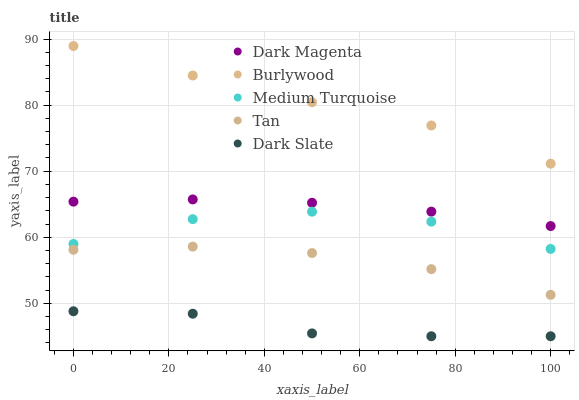Does Dark Slate have the minimum area under the curve?
Answer yes or no. Yes. Does Burlywood have the maximum area under the curve?
Answer yes or no. Yes. Does Tan have the minimum area under the curve?
Answer yes or no. No. Does Tan have the maximum area under the curve?
Answer yes or no. No. Is Dark Magenta the smoothest?
Answer yes or no. Yes. Is Medium Turquoise the roughest?
Answer yes or no. Yes. Is Dark Slate the smoothest?
Answer yes or no. No. Is Dark Slate the roughest?
Answer yes or no. No. Does Dark Slate have the lowest value?
Answer yes or no. Yes. Does Tan have the lowest value?
Answer yes or no. No. Does Burlywood have the highest value?
Answer yes or no. Yes. Does Tan have the highest value?
Answer yes or no. No. Is Dark Slate less than Burlywood?
Answer yes or no. Yes. Is Medium Turquoise greater than Dark Slate?
Answer yes or no. Yes. Does Dark Slate intersect Burlywood?
Answer yes or no. No. 